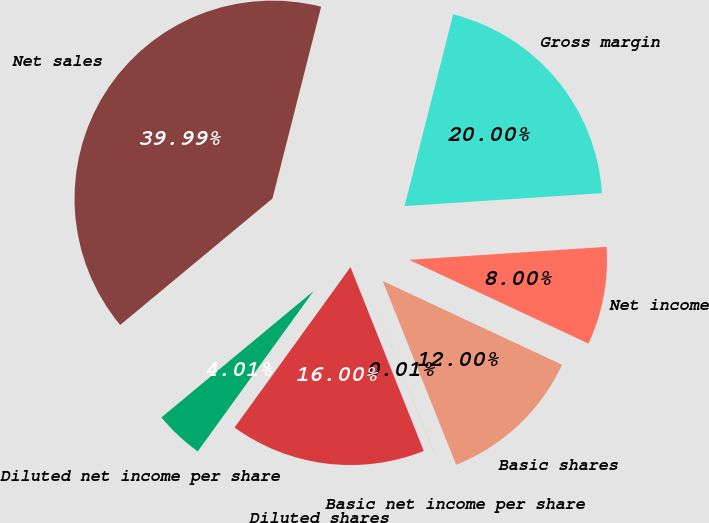<chart> <loc_0><loc_0><loc_500><loc_500><pie_chart><fcel>Net sales<fcel>Gross margin<fcel>Net income<fcel>Basic shares<fcel>Basic net income per share<fcel>Diluted shares<fcel>Diluted net income per share<nl><fcel>39.99%<fcel>20.0%<fcel>8.0%<fcel>12.0%<fcel>0.01%<fcel>16.0%<fcel>4.01%<nl></chart> 